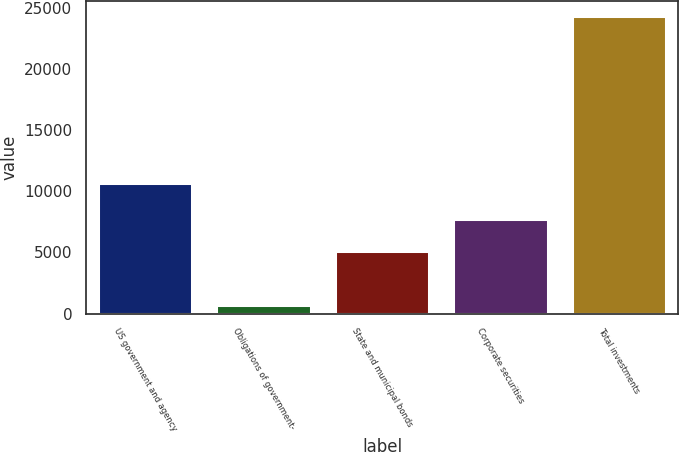<chart> <loc_0><loc_0><loc_500><loc_500><bar_chart><fcel>US government and agency<fcel>Obligations of government-<fcel>State and municipal bonds<fcel>Corporate securities<fcel>Total investments<nl><fcel>10720<fcel>705<fcel>5156<fcel>7779<fcel>24360<nl></chart> 